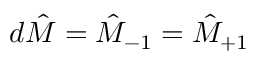<formula> <loc_0><loc_0><loc_500><loc_500>d \hat { M } = \hat { M } _ { - 1 } = \hat { M } _ { + 1 }</formula> 